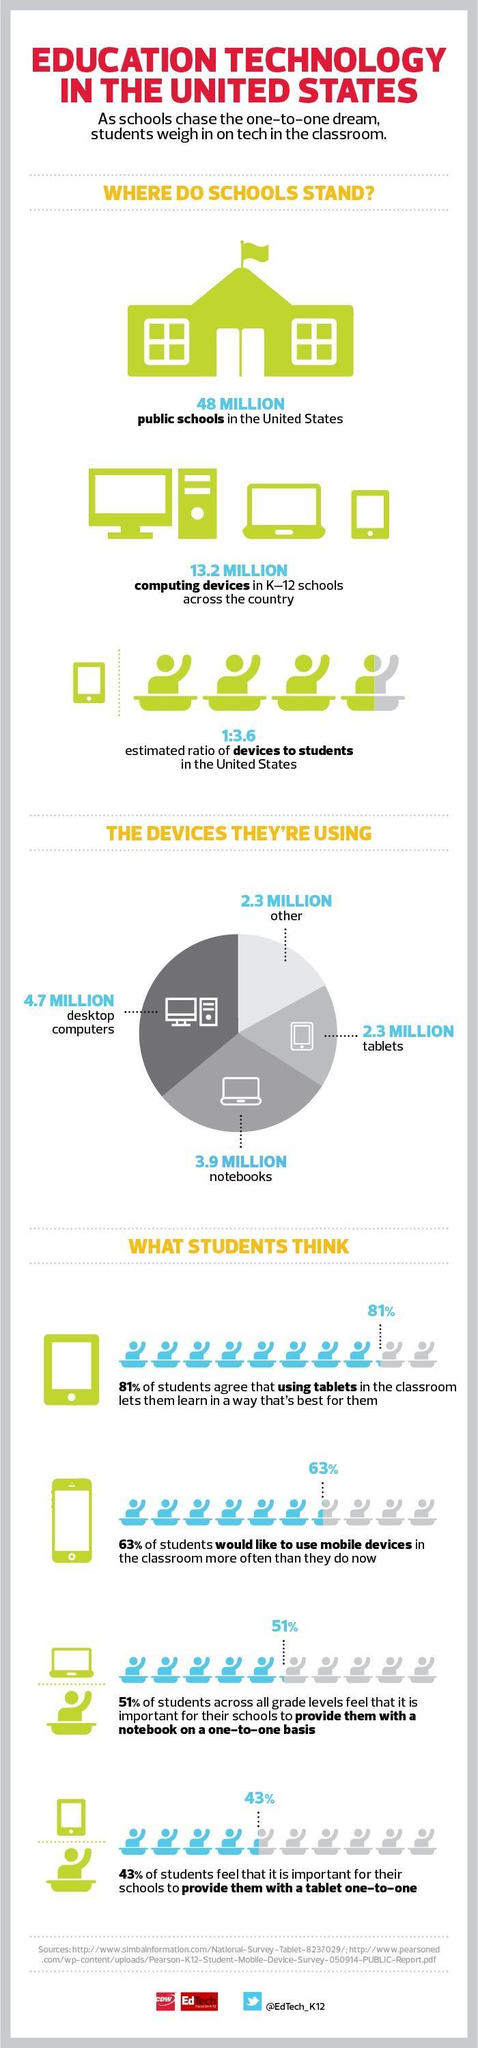What percentage of students feel that it is not important for schools to provide them with a tablet one-to-one?
Answer the question with a short phrase. 57% Which is the second most used device by students? notebooks 